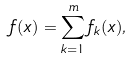Convert formula to latex. <formula><loc_0><loc_0><loc_500><loc_500>f ( x ) = \sum _ { k = 1 } ^ { m } f _ { k } ( x ) ,</formula> 